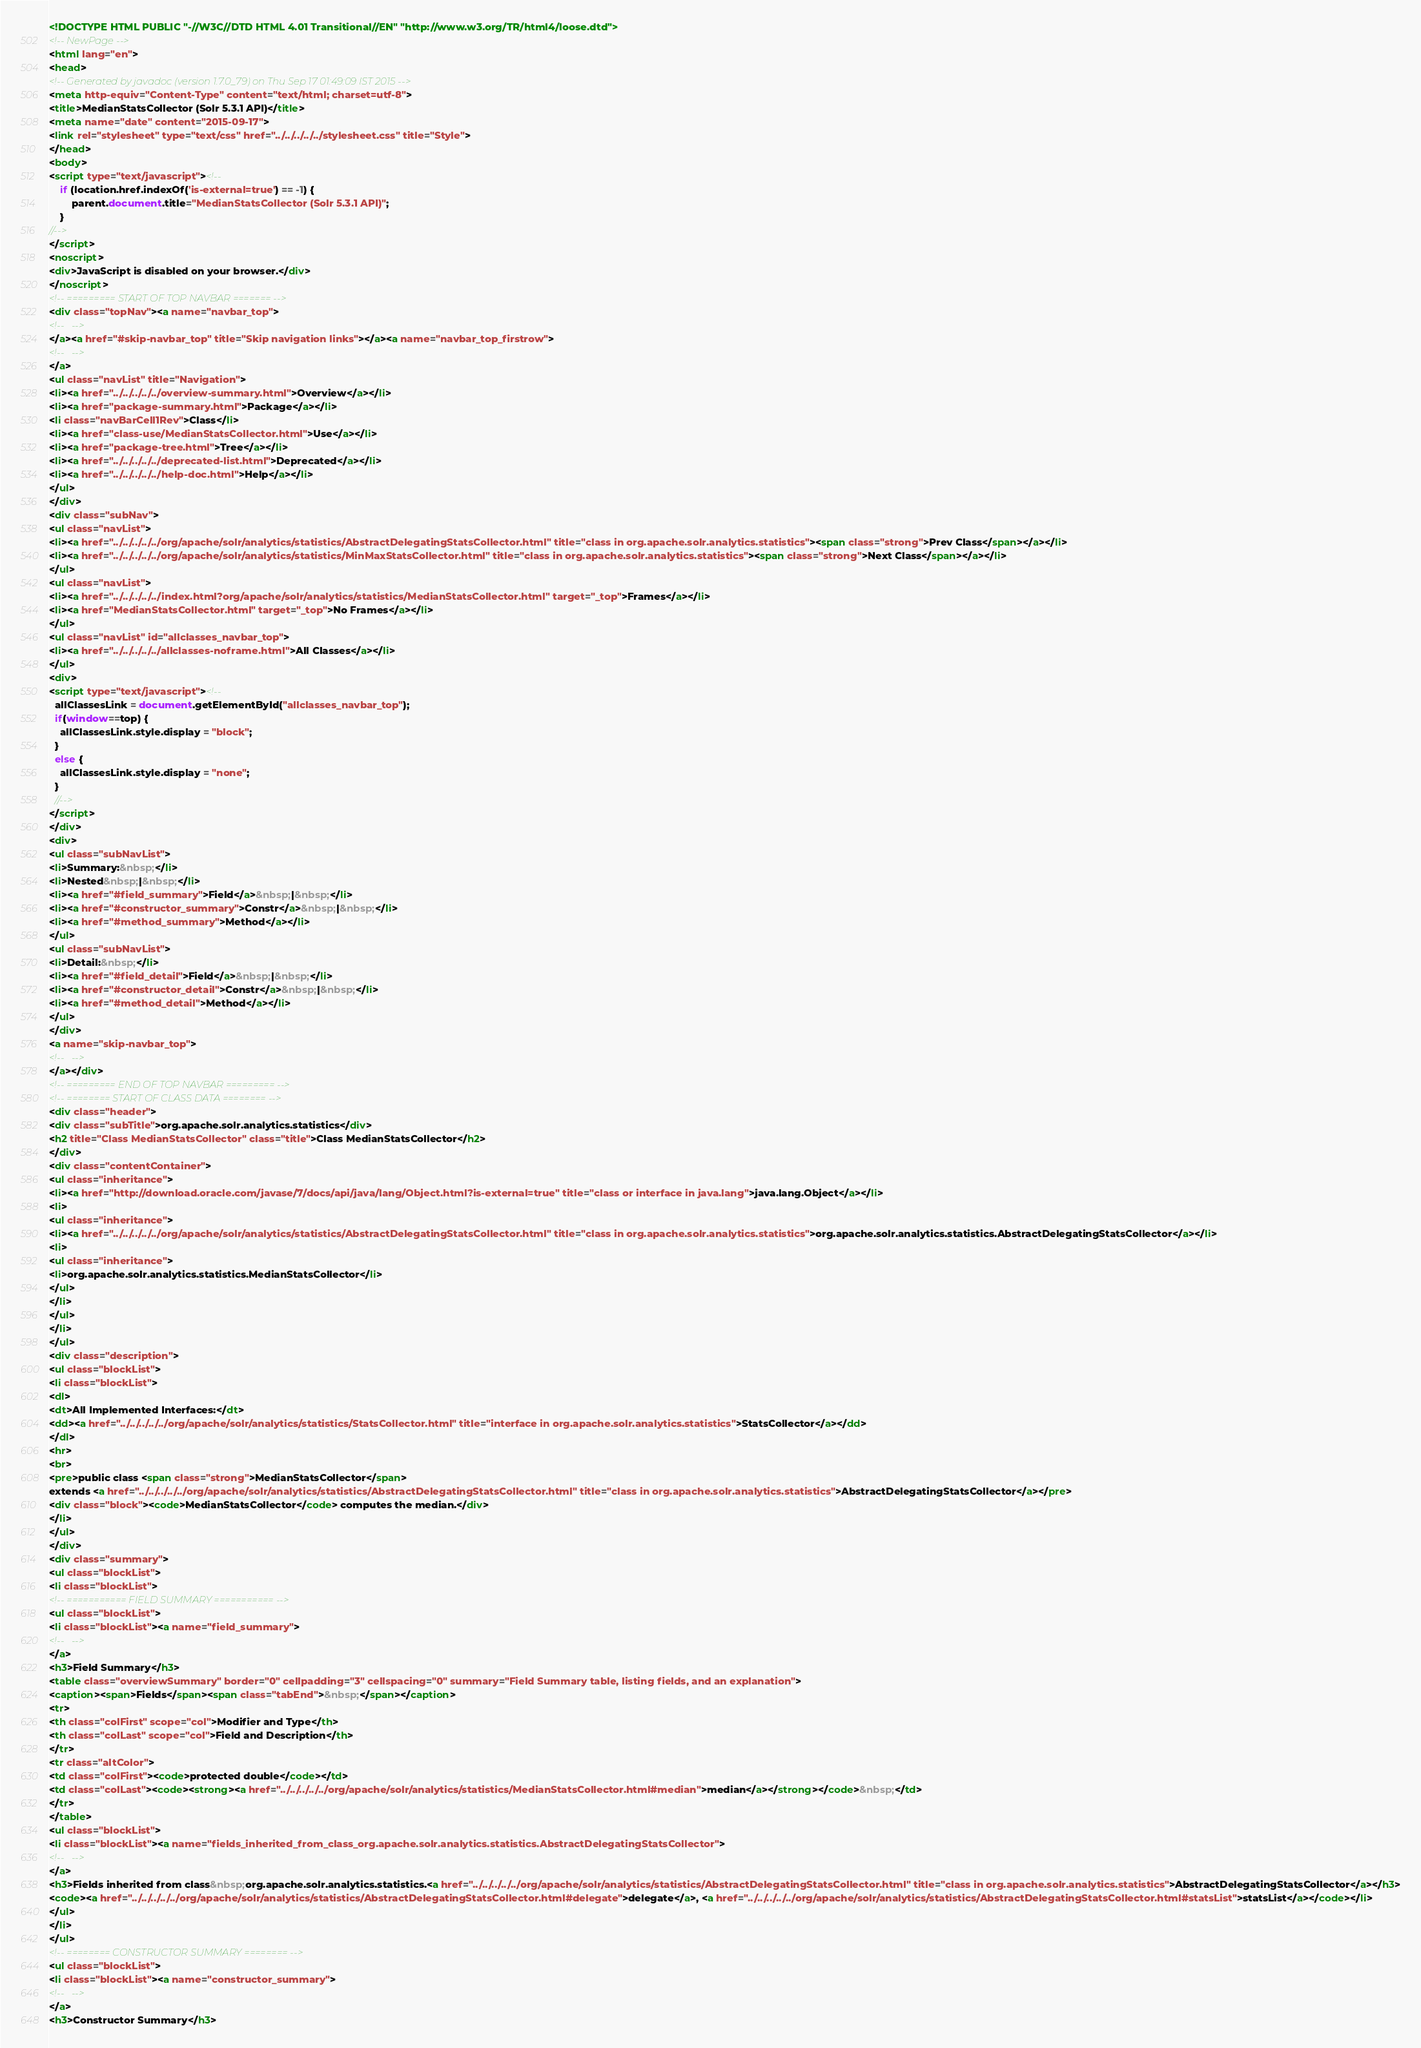Convert code to text. <code><loc_0><loc_0><loc_500><loc_500><_HTML_><!DOCTYPE HTML PUBLIC "-//W3C//DTD HTML 4.01 Transitional//EN" "http://www.w3.org/TR/html4/loose.dtd">
<!-- NewPage -->
<html lang="en">
<head>
<!-- Generated by javadoc (version 1.7.0_79) on Thu Sep 17 01:49:09 IST 2015 -->
<meta http-equiv="Content-Type" content="text/html; charset=utf-8">
<title>MedianStatsCollector (Solr 5.3.1 API)</title>
<meta name="date" content="2015-09-17">
<link rel="stylesheet" type="text/css" href="../../../../../stylesheet.css" title="Style">
</head>
<body>
<script type="text/javascript"><!--
    if (location.href.indexOf('is-external=true') == -1) {
        parent.document.title="MedianStatsCollector (Solr 5.3.1 API)";
    }
//-->
</script>
<noscript>
<div>JavaScript is disabled on your browser.</div>
</noscript>
<!-- ========= START OF TOP NAVBAR ======= -->
<div class="topNav"><a name="navbar_top">
<!--   -->
</a><a href="#skip-navbar_top" title="Skip navigation links"></a><a name="navbar_top_firstrow">
<!--   -->
</a>
<ul class="navList" title="Navigation">
<li><a href="../../../../../overview-summary.html">Overview</a></li>
<li><a href="package-summary.html">Package</a></li>
<li class="navBarCell1Rev">Class</li>
<li><a href="class-use/MedianStatsCollector.html">Use</a></li>
<li><a href="package-tree.html">Tree</a></li>
<li><a href="../../../../../deprecated-list.html">Deprecated</a></li>
<li><a href="../../../../../help-doc.html">Help</a></li>
</ul>
</div>
<div class="subNav">
<ul class="navList">
<li><a href="../../../../../org/apache/solr/analytics/statistics/AbstractDelegatingStatsCollector.html" title="class in org.apache.solr.analytics.statistics"><span class="strong">Prev Class</span></a></li>
<li><a href="../../../../../org/apache/solr/analytics/statistics/MinMaxStatsCollector.html" title="class in org.apache.solr.analytics.statistics"><span class="strong">Next Class</span></a></li>
</ul>
<ul class="navList">
<li><a href="../../../../../index.html?org/apache/solr/analytics/statistics/MedianStatsCollector.html" target="_top">Frames</a></li>
<li><a href="MedianStatsCollector.html" target="_top">No Frames</a></li>
</ul>
<ul class="navList" id="allclasses_navbar_top">
<li><a href="../../../../../allclasses-noframe.html">All Classes</a></li>
</ul>
<div>
<script type="text/javascript"><!--
  allClassesLink = document.getElementById("allclasses_navbar_top");
  if(window==top) {
    allClassesLink.style.display = "block";
  }
  else {
    allClassesLink.style.display = "none";
  }
  //-->
</script>
</div>
<div>
<ul class="subNavList">
<li>Summary:&nbsp;</li>
<li>Nested&nbsp;|&nbsp;</li>
<li><a href="#field_summary">Field</a>&nbsp;|&nbsp;</li>
<li><a href="#constructor_summary">Constr</a>&nbsp;|&nbsp;</li>
<li><a href="#method_summary">Method</a></li>
</ul>
<ul class="subNavList">
<li>Detail:&nbsp;</li>
<li><a href="#field_detail">Field</a>&nbsp;|&nbsp;</li>
<li><a href="#constructor_detail">Constr</a>&nbsp;|&nbsp;</li>
<li><a href="#method_detail">Method</a></li>
</ul>
</div>
<a name="skip-navbar_top">
<!--   -->
</a></div>
<!-- ========= END OF TOP NAVBAR ========= -->
<!-- ======== START OF CLASS DATA ======== -->
<div class="header">
<div class="subTitle">org.apache.solr.analytics.statistics</div>
<h2 title="Class MedianStatsCollector" class="title">Class MedianStatsCollector</h2>
</div>
<div class="contentContainer">
<ul class="inheritance">
<li><a href="http://download.oracle.com/javase/7/docs/api/java/lang/Object.html?is-external=true" title="class or interface in java.lang">java.lang.Object</a></li>
<li>
<ul class="inheritance">
<li><a href="../../../../../org/apache/solr/analytics/statistics/AbstractDelegatingStatsCollector.html" title="class in org.apache.solr.analytics.statistics">org.apache.solr.analytics.statistics.AbstractDelegatingStatsCollector</a></li>
<li>
<ul class="inheritance">
<li>org.apache.solr.analytics.statistics.MedianStatsCollector</li>
</ul>
</li>
</ul>
</li>
</ul>
<div class="description">
<ul class="blockList">
<li class="blockList">
<dl>
<dt>All Implemented Interfaces:</dt>
<dd><a href="../../../../../org/apache/solr/analytics/statistics/StatsCollector.html" title="interface in org.apache.solr.analytics.statistics">StatsCollector</a></dd>
</dl>
<hr>
<br>
<pre>public class <span class="strong">MedianStatsCollector</span>
extends <a href="../../../../../org/apache/solr/analytics/statistics/AbstractDelegatingStatsCollector.html" title="class in org.apache.solr.analytics.statistics">AbstractDelegatingStatsCollector</a></pre>
<div class="block"><code>MedianStatsCollector</code> computes the median.</div>
</li>
</ul>
</div>
<div class="summary">
<ul class="blockList">
<li class="blockList">
<!-- =========== FIELD SUMMARY =========== -->
<ul class="blockList">
<li class="blockList"><a name="field_summary">
<!--   -->
</a>
<h3>Field Summary</h3>
<table class="overviewSummary" border="0" cellpadding="3" cellspacing="0" summary="Field Summary table, listing fields, and an explanation">
<caption><span>Fields</span><span class="tabEnd">&nbsp;</span></caption>
<tr>
<th class="colFirst" scope="col">Modifier and Type</th>
<th class="colLast" scope="col">Field and Description</th>
</tr>
<tr class="altColor">
<td class="colFirst"><code>protected double</code></td>
<td class="colLast"><code><strong><a href="../../../../../org/apache/solr/analytics/statistics/MedianStatsCollector.html#median">median</a></strong></code>&nbsp;</td>
</tr>
</table>
<ul class="blockList">
<li class="blockList"><a name="fields_inherited_from_class_org.apache.solr.analytics.statistics.AbstractDelegatingStatsCollector">
<!--   -->
</a>
<h3>Fields inherited from class&nbsp;org.apache.solr.analytics.statistics.<a href="../../../../../org/apache/solr/analytics/statistics/AbstractDelegatingStatsCollector.html" title="class in org.apache.solr.analytics.statistics">AbstractDelegatingStatsCollector</a></h3>
<code><a href="../../../../../org/apache/solr/analytics/statistics/AbstractDelegatingStatsCollector.html#delegate">delegate</a>, <a href="../../../../../org/apache/solr/analytics/statistics/AbstractDelegatingStatsCollector.html#statsList">statsList</a></code></li>
</ul>
</li>
</ul>
<!-- ======== CONSTRUCTOR SUMMARY ======== -->
<ul class="blockList">
<li class="blockList"><a name="constructor_summary">
<!--   -->
</a>
<h3>Constructor Summary</h3></code> 